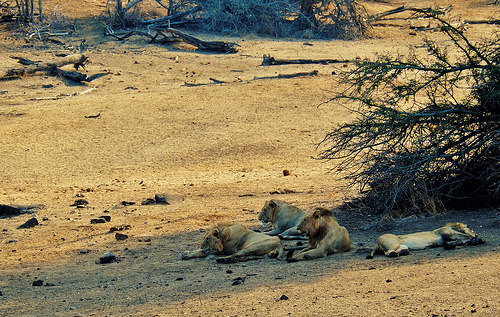<image>
Is there a lion behind the bush? No. The lion is not behind the bush. From this viewpoint, the lion appears to be positioned elsewhere in the scene. 